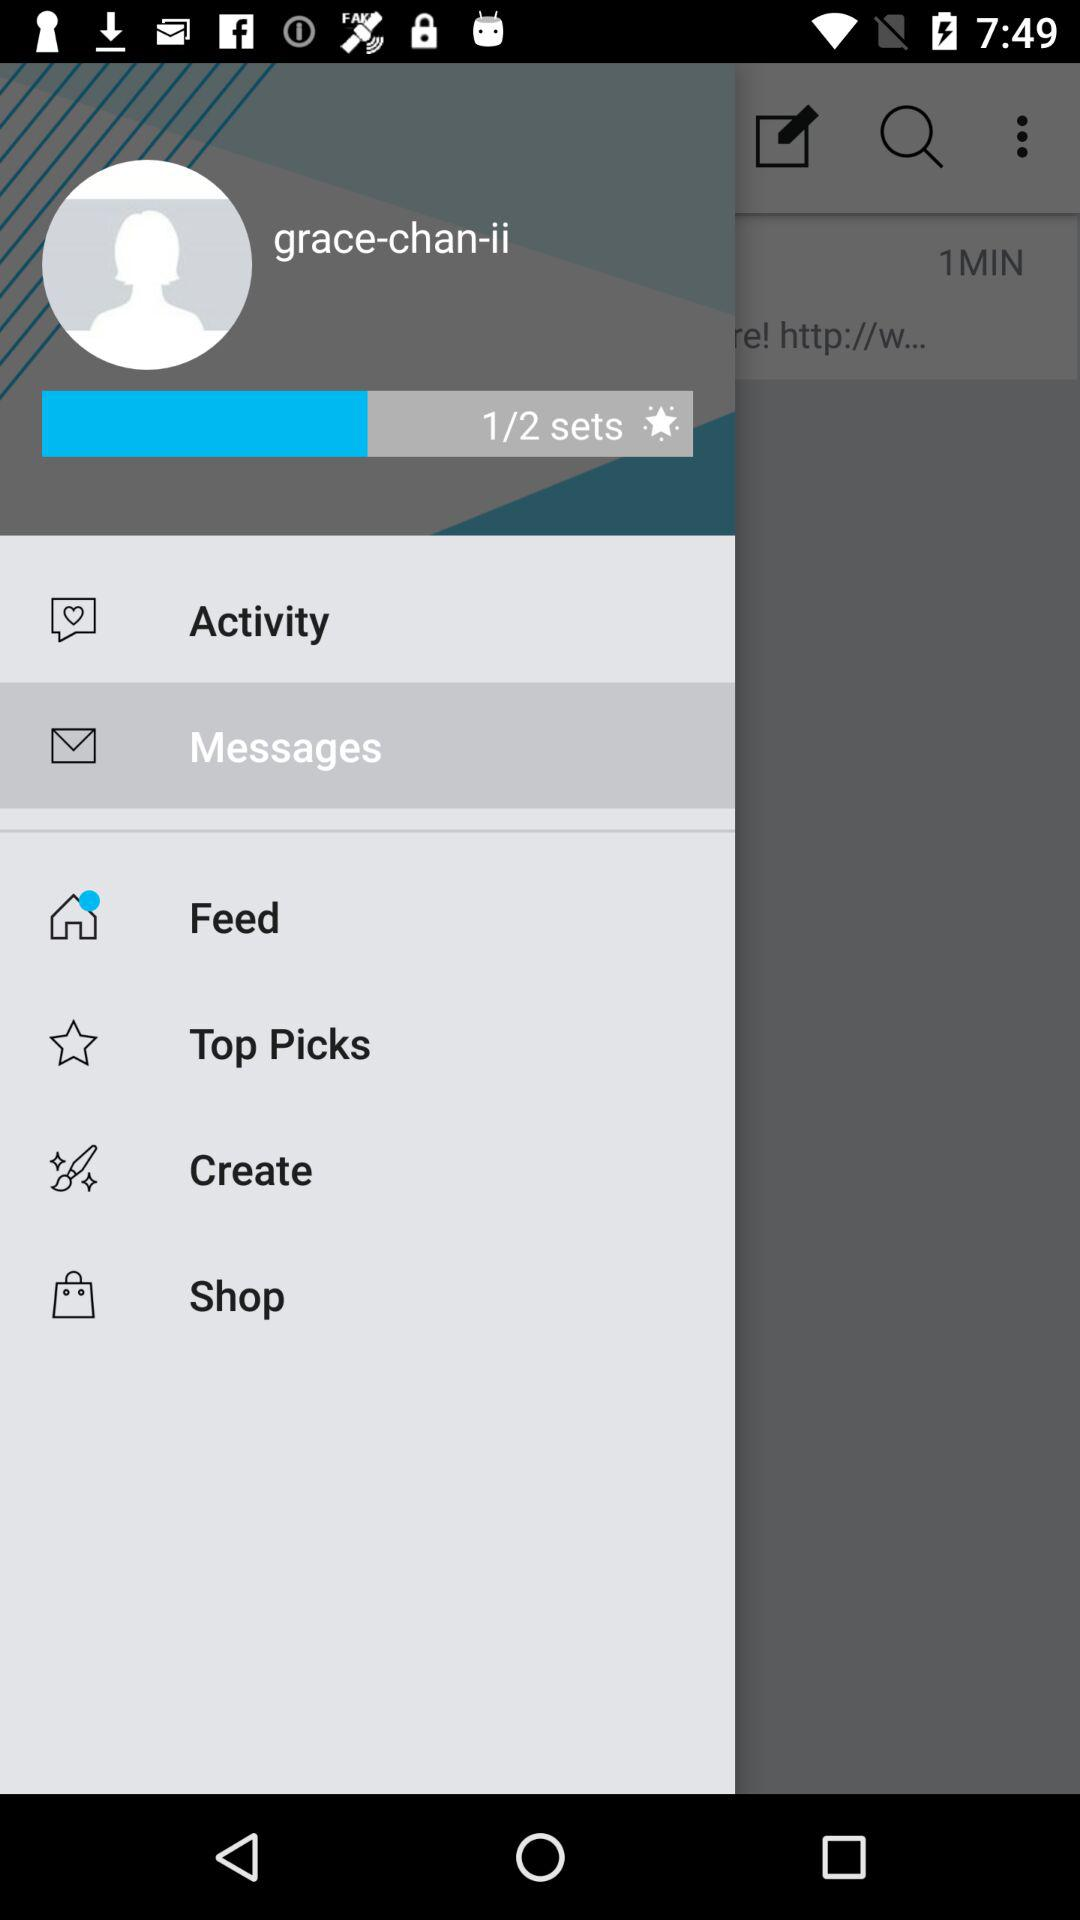How many sets in total are there? There are total 2 sets. 